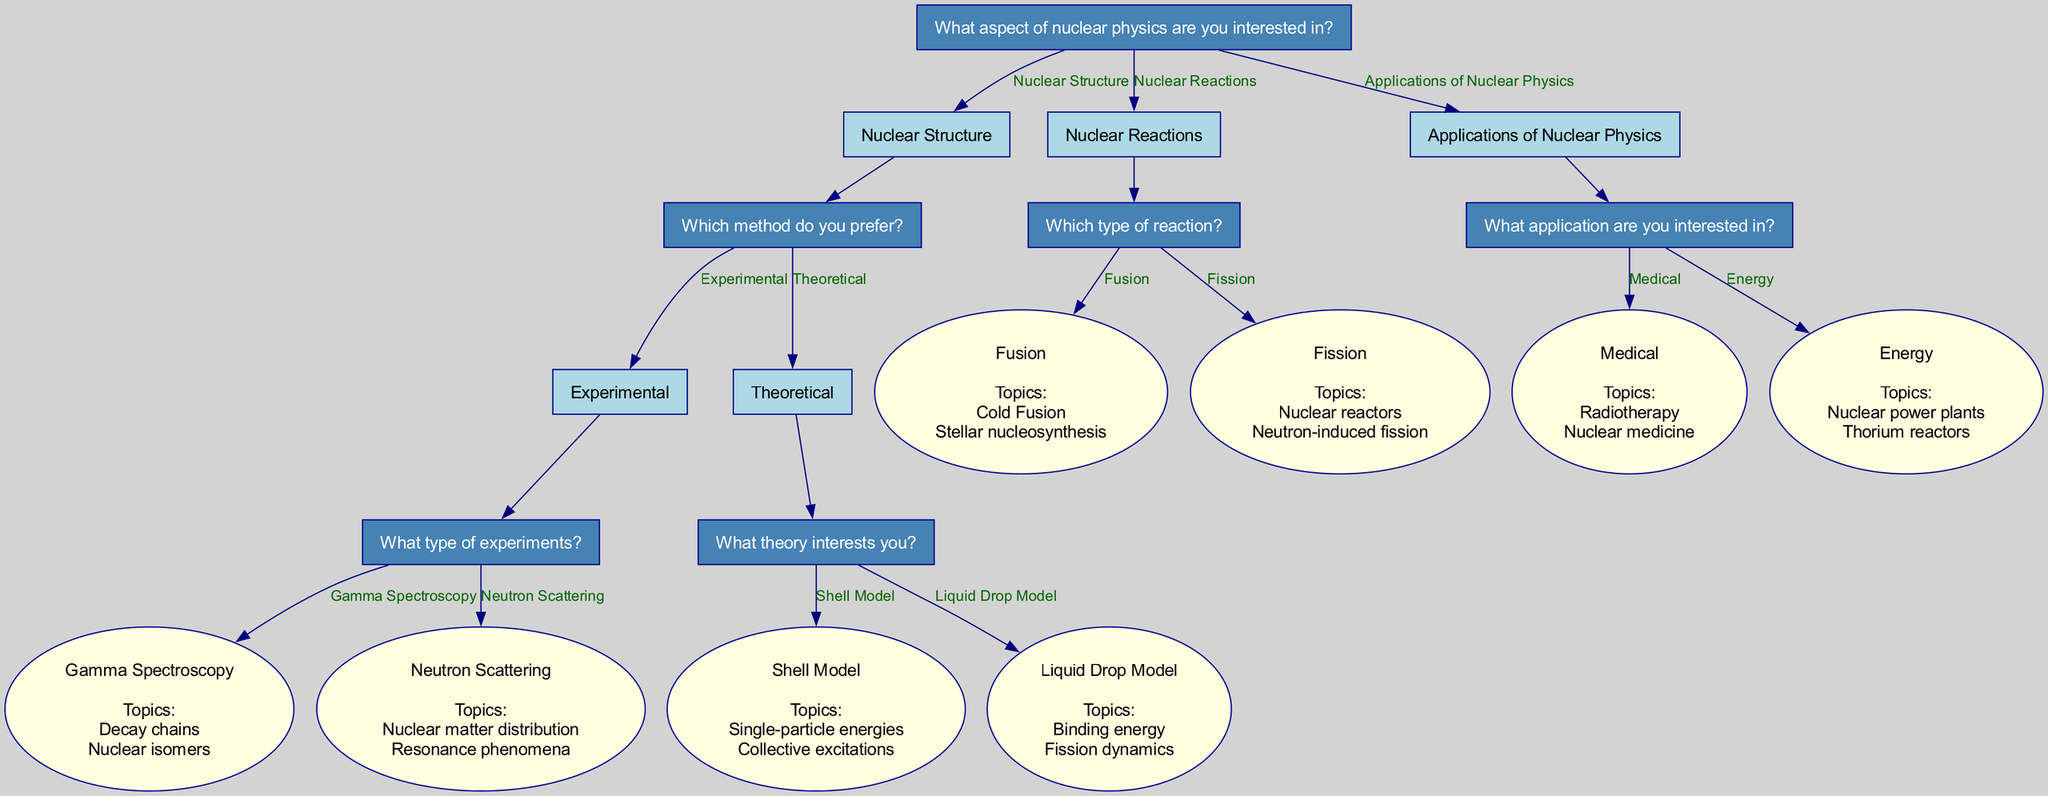What is the root question in the diagram? The root question is "What aspect of nuclear physics are you interested in?" which is the first question that branches out into different options.
Answer: What aspect of nuclear physics are you interested in? How many main options are there under the root question? The root question has three main options: Nuclear Structure, Nuclear Reactions, and Applications of Nuclear Physics, totaling three distinct paths.
Answer: 3 What are the research topics for the 'Fusion' reaction? In the 'Nuclear Reactions' section, if 'Fusion' is selected, the research topics listed are "Cold Fusion" and "Stellar nucleosynthesis".
Answer: Cold Fusion, Stellar nucleosynthesis What method is linked to 'Gamma Spectroscopy'? In the 'Nuclear Structure' section, if 'Experimental' is chosen, selecting 'Gamma Spectroscopy' leads to research topics "Decay chains" and "Nuclear isomers", indicating its association with this method.
Answer: Experimental Which theory is associated with the 'Liquid Drop Model'? Under the 'Nuclear Structure' section, if 'Theoretical' is chosen, selecting 'Liquid Drop Model' will show the research topics "Binding energy" and "Fission dynamics", which tells us which topics are connected to this theory.
Answer: Binding energy, Fission dynamics If a student is interested in 'Nuclear medicine', where do they branch from the root? Starting from the root, they would first select 'Applications of Nuclear Physics', then select 'Medical' to reach the research topics related to 'Nuclear medicine'.
Answer: Applications of Nuclear Physics, Medical Which option leads to 'Neutron-induced fission'? The path to 'Neutron-induced fission' starts from 'Nuclear Reactions'. First, the student selects 'Fission', which presents 'Nuclear reactors' and 'Neutron-induced fission' as research topics.
Answer: Fission How many research topics can be found under 'Theoretical' methods? In the 'Nuclear Structure' section, selecting 'Theoretical' provides two theories: 'Shell Model' (with two topics) and 'Liquid Drop Model' (with two topics), leading to a total of four research topics under theoretical methods.
Answer: 4 What type of questions does the decision tree aim to address? The decision tree is designed to help students identify specific research topics in nuclear physics based on their interests across multiple branches and methods.
Answer: Research topic selection 